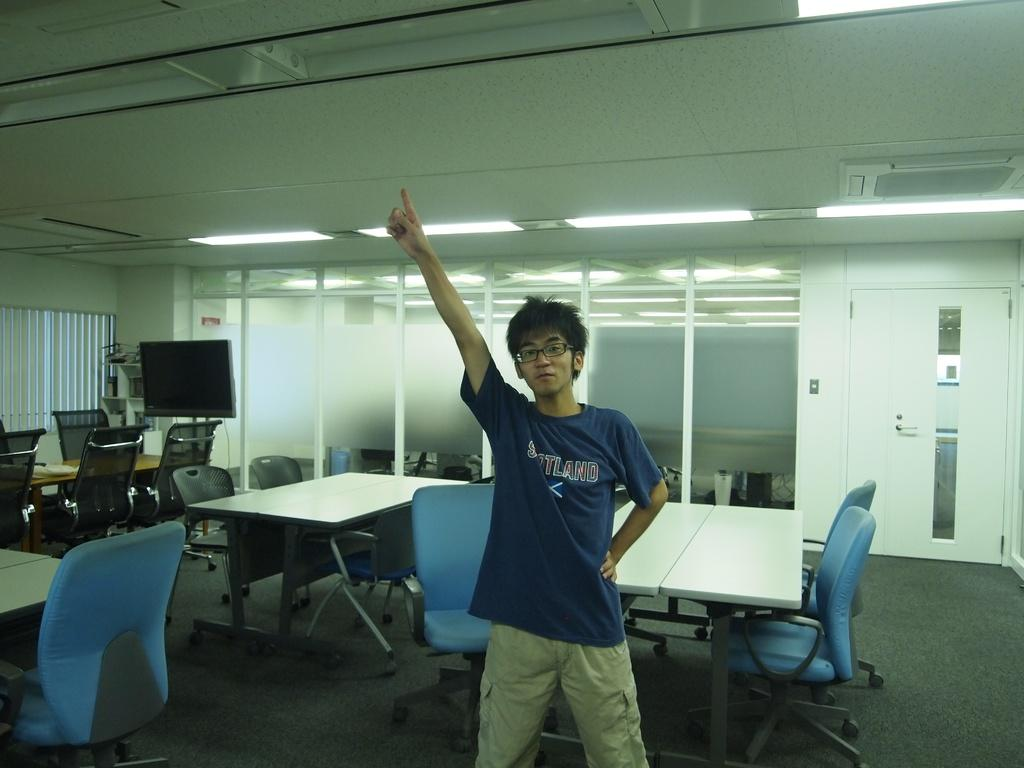What is the main subject in the image? There is a person standing in the image. What type of furniture is visible in the image? There are tables and chairs present in the image. Are the chairs stationary or moving? The chairs are moving in the image. What can be seen on the wall in the image? There is a TV screen on the wall in the image. How many cacti are present in the image? There are no cacti visible in the image. What type of police activity is happening in the image? There is no police activity present in the image. 